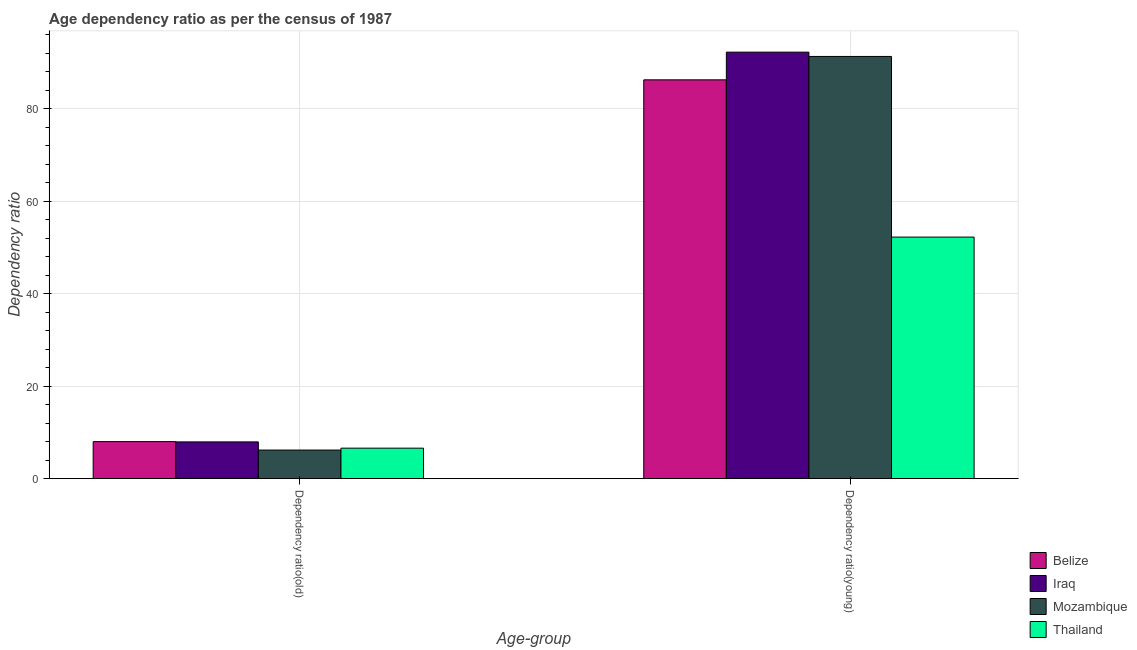How many bars are there on the 2nd tick from the right?
Your response must be concise. 4. What is the label of the 1st group of bars from the left?
Offer a terse response. Dependency ratio(old). What is the age dependency ratio(young) in Thailand?
Provide a succinct answer. 52.24. Across all countries, what is the maximum age dependency ratio(old)?
Offer a very short reply. 8. Across all countries, what is the minimum age dependency ratio(old)?
Your answer should be very brief. 6.18. In which country was the age dependency ratio(young) maximum?
Offer a terse response. Iraq. In which country was the age dependency ratio(young) minimum?
Provide a succinct answer. Thailand. What is the total age dependency ratio(old) in the graph?
Your response must be concise. 28.7. What is the difference between the age dependency ratio(young) in Mozambique and that in Thailand?
Make the answer very short. 39.07. What is the difference between the age dependency ratio(young) in Thailand and the age dependency ratio(old) in Iraq?
Your answer should be very brief. 44.3. What is the average age dependency ratio(old) per country?
Offer a terse response. 7.18. What is the difference between the age dependency ratio(young) and age dependency ratio(old) in Thailand?
Your response must be concise. 45.65. What is the ratio of the age dependency ratio(young) in Mozambique to that in Thailand?
Provide a short and direct response. 1.75. Is the age dependency ratio(young) in Belize less than that in Iraq?
Make the answer very short. Yes. What does the 2nd bar from the left in Dependency ratio(young) represents?
Give a very brief answer. Iraq. What does the 1st bar from the right in Dependency ratio(young) represents?
Offer a very short reply. Thailand. How many bars are there?
Ensure brevity in your answer.  8. Are all the bars in the graph horizontal?
Make the answer very short. No. Are the values on the major ticks of Y-axis written in scientific E-notation?
Provide a short and direct response. No. Does the graph contain grids?
Your answer should be very brief. Yes. Where does the legend appear in the graph?
Give a very brief answer. Bottom right. What is the title of the graph?
Offer a very short reply. Age dependency ratio as per the census of 1987. What is the label or title of the X-axis?
Your response must be concise. Age-group. What is the label or title of the Y-axis?
Your answer should be compact. Dependency ratio. What is the Dependency ratio in Belize in Dependency ratio(old)?
Offer a terse response. 8. What is the Dependency ratio in Iraq in Dependency ratio(old)?
Your answer should be very brief. 7.94. What is the Dependency ratio in Mozambique in Dependency ratio(old)?
Your response must be concise. 6.18. What is the Dependency ratio in Thailand in Dependency ratio(old)?
Your answer should be compact. 6.59. What is the Dependency ratio of Belize in Dependency ratio(young)?
Keep it short and to the point. 86.25. What is the Dependency ratio of Iraq in Dependency ratio(young)?
Give a very brief answer. 92.24. What is the Dependency ratio in Mozambique in Dependency ratio(young)?
Offer a very short reply. 91.31. What is the Dependency ratio in Thailand in Dependency ratio(young)?
Offer a terse response. 52.24. Across all Age-group, what is the maximum Dependency ratio of Belize?
Your response must be concise. 86.25. Across all Age-group, what is the maximum Dependency ratio of Iraq?
Offer a very short reply. 92.24. Across all Age-group, what is the maximum Dependency ratio of Mozambique?
Make the answer very short. 91.31. Across all Age-group, what is the maximum Dependency ratio of Thailand?
Offer a very short reply. 52.24. Across all Age-group, what is the minimum Dependency ratio of Belize?
Your response must be concise. 8. Across all Age-group, what is the minimum Dependency ratio in Iraq?
Your answer should be compact. 7.94. Across all Age-group, what is the minimum Dependency ratio in Mozambique?
Keep it short and to the point. 6.18. Across all Age-group, what is the minimum Dependency ratio of Thailand?
Provide a short and direct response. 6.59. What is the total Dependency ratio of Belize in the graph?
Provide a succinct answer. 94.25. What is the total Dependency ratio of Iraq in the graph?
Your answer should be very brief. 100.17. What is the total Dependency ratio of Mozambique in the graph?
Make the answer very short. 97.48. What is the total Dependency ratio in Thailand in the graph?
Make the answer very short. 58.82. What is the difference between the Dependency ratio of Belize in Dependency ratio(old) and that in Dependency ratio(young)?
Provide a succinct answer. -78.24. What is the difference between the Dependency ratio in Iraq in Dependency ratio(old) and that in Dependency ratio(young)?
Provide a short and direct response. -84.3. What is the difference between the Dependency ratio in Mozambique in Dependency ratio(old) and that in Dependency ratio(young)?
Offer a terse response. -85.13. What is the difference between the Dependency ratio in Thailand in Dependency ratio(old) and that in Dependency ratio(young)?
Offer a terse response. -45.65. What is the difference between the Dependency ratio of Belize in Dependency ratio(old) and the Dependency ratio of Iraq in Dependency ratio(young)?
Offer a terse response. -84.23. What is the difference between the Dependency ratio of Belize in Dependency ratio(old) and the Dependency ratio of Mozambique in Dependency ratio(young)?
Keep it short and to the point. -83.3. What is the difference between the Dependency ratio in Belize in Dependency ratio(old) and the Dependency ratio in Thailand in Dependency ratio(young)?
Ensure brevity in your answer.  -44.24. What is the difference between the Dependency ratio of Iraq in Dependency ratio(old) and the Dependency ratio of Mozambique in Dependency ratio(young)?
Provide a short and direct response. -83.37. What is the difference between the Dependency ratio in Iraq in Dependency ratio(old) and the Dependency ratio in Thailand in Dependency ratio(young)?
Provide a short and direct response. -44.3. What is the difference between the Dependency ratio of Mozambique in Dependency ratio(old) and the Dependency ratio of Thailand in Dependency ratio(young)?
Ensure brevity in your answer.  -46.06. What is the average Dependency ratio of Belize per Age-group?
Offer a very short reply. 47.12. What is the average Dependency ratio of Iraq per Age-group?
Your answer should be very brief. 50.09. What is the average Dependency ratio of Mozambique per Age-group?
Provide a short and direct response. 48.74. What is the average Dependency ratio of Thailand per Age-group?
Offer a very short reply. 29.41. What is the difference between the Dependency ratio of Belize and Dependency ratio of Iraq in Dependency ratio(old)?
Make the answer very short. 0.06. What is the difference between the Dependency ratio of Belize and Dependency ratio of Mozambique in Dependency ratio(old)?
Your response must be concise. 1.83. What is the difference between the Dependency ratio in Belize and Dependency ratio in Thailand in Dependency ratio(old)?
Offer a terse response. 1.42. What is the difference between the Dependency ratio of Iraq and Dependency ratio of Mozambique in Dependency ratio(old)?
Your answer should be very brief. 1.76. What is the difference between the Dependency ratio of Iraq and Dependency ratio of Thailand in Dependency ratio(old)?
Keep it short and to the point. 1.35. What is the difference between the Dependency ratio of Mozambique and Dependency ratio of Thailand in Dependency ratio(old)?
Give a very brief answer. -0.41. What is the difference between the Dependency ratio of Belize and Dependency ratio of Iraq in Dependency ratio(young)?
Give a very brief answer. -5.99. What is the difference between the Dependency ratio in Belize and Dependency ratio in Mozambique in Dependency ratio(young)?
Provide a short and direct response. -5.06. What is the difference between the Dependency ratio in Belize and Dependency ratio in Thailand in Dependency ratio(young)?
Give a very brief answer. 34.01. What is the difference between the Dependency ratio in Iraq and Dependency ratio in Mozambique in Dependency ratio(young)?
Offer a very short reply. 0.93. What is the difference between the Dependency ratio in Iraq and Dependency ratio in Thailand in Dependency ratio(young)?
Make the answer very short. 40. What is the difference between the Dependency ratio of Mozambique and Dependency ratio of Thailand in Dependency ratio(young)?
Provide a succinct answer. 39.07. What is the ratio of the Dependency ratio in Belize in Dependency ratio(old) to that in Dependency ratio(young)?
Provide a succinct answer. 0.09. What is the ratio of the Dependency ratio in Iraq in Dependency ratio(old) to that in Dependency ratio(young)?
Give a very brief answer. 0.09. What is the ratio of the Dependency ratio of Mozambique in Dependency ratio(old) to that in Dependency ratio(young)?
Provide a succinct answer. 0.07. What is the ratio of the Dependency ratio of Thailand in Dependency ratio(old) to that in Dependency ratio(young)?
Offer a very short reply. 0.13. What is the difference between the highest and the second highest Dependency ratio of Belize?
Your answer should be very brief. 78.24. What is the difference between the highest and the second highest Dependency ratio of Iraq?
Your response must be concise. 84.3. What is the difference between the highest and the second highest Dependency ratio of Mozambique?
Your answer should be very brief. 85.13. What is the difference between the highest and the second highest Dependency ratio of Thailand?
Your answer should be very brief. 45.65. What is the difference between the highest and the lowest Dependency ratio of Belize?
Your response must be concise. 78.24. What is the difference between the highest and the lowest Dependency ratio of Iraq?
Your answer should be very brief. 84.3. What is the difference between the highest and the lowest Dependency ratio of Mozambique?
Your answer should be very brief. 85.13. What is the difference between the highest and the lowest Dependency ratio of Thailand?
Provide a succinct answer. 45.65. 